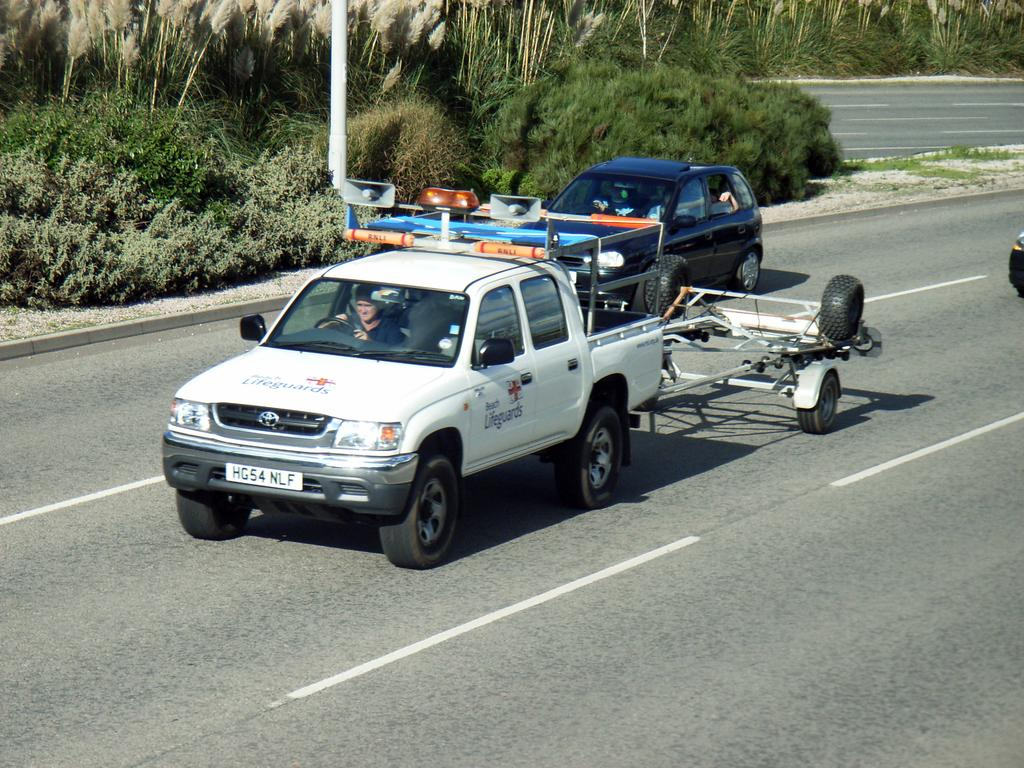What is the main feature of the image? There is a road in the image. What is happening on the road? There are two cars on the road. What type of vegetation can be seen in the image? There are green color plants and trees in the image. What is the price of the surprise that the ants are carrying in the image? There are no ants or surprises present in the image, so it is not possible to determine a price. 